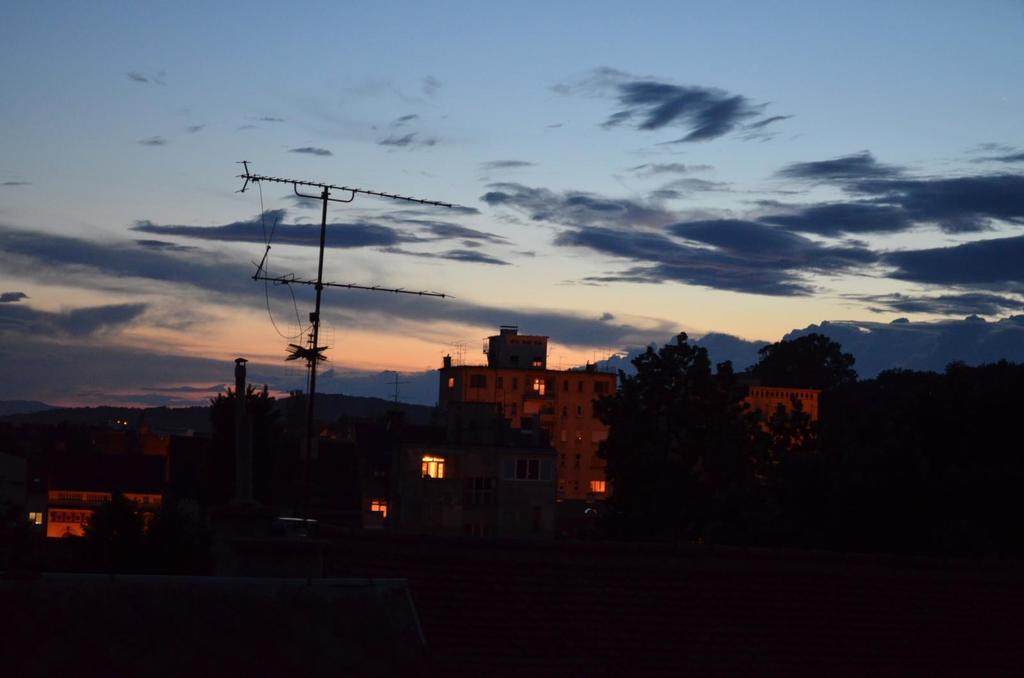How would you summarize this image in a sentence or two? In the middle of the image it is dark and we can see buildings, trees and antennae. In the background of the image we can see sky with clouds. 